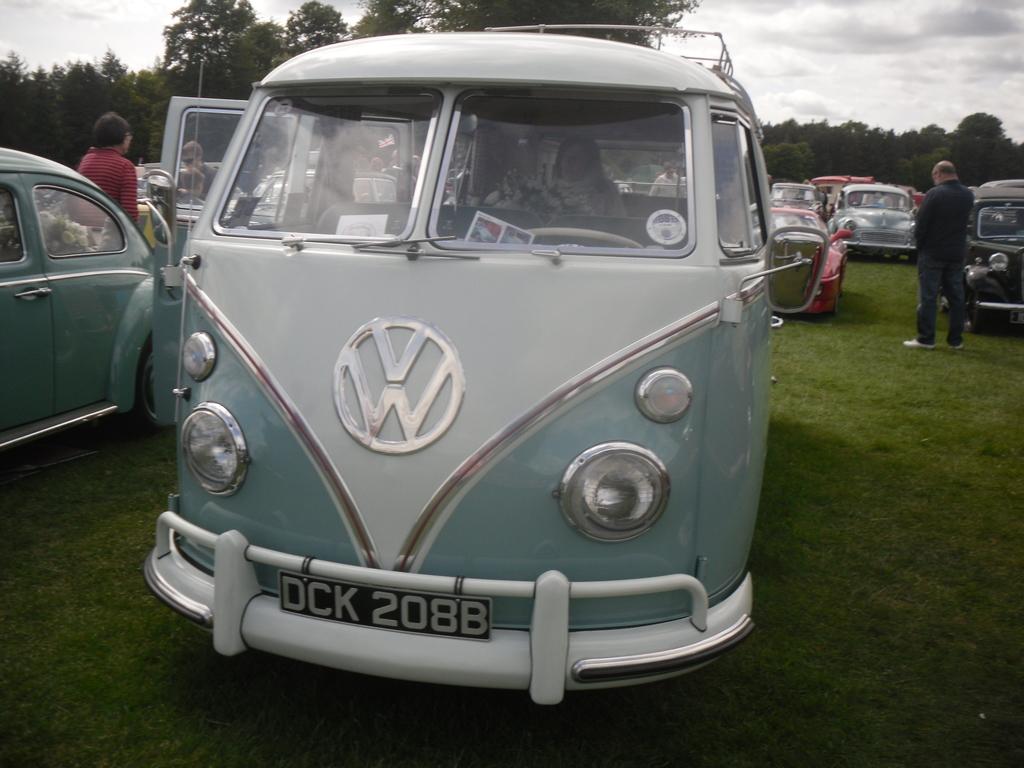What is the license plate?
Give a very brief answer. Dck 2088. What is the make of the van?
Your answer should be very brief. Volkswagon. 